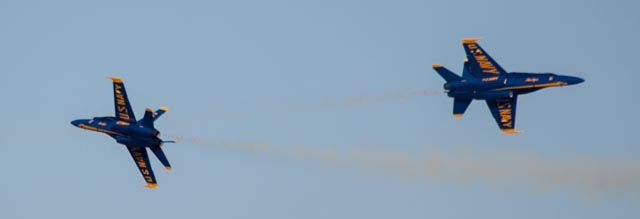Please extract the text content from this image. USNA 